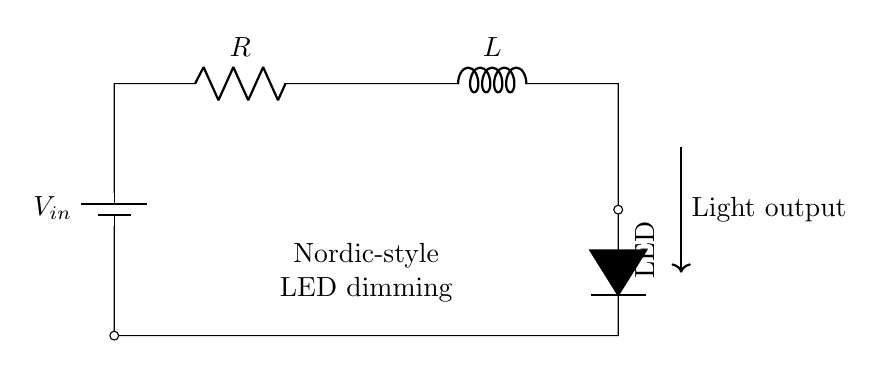What is the input voltage of this circuit? The input voltage, indicated by \(V_{in}\), represents the potential supplied by the battery connected at the top of the circuit. Since no specific value is provided in the diagram, we acknowledge it generically as \(V_{in}\).
Answer: \(V_{in}\) What type of components are present in this circuit? The circuit contains two fundamental components: a resistor \(R\) and an inductor \(L\). Additionally, there is a light-emitting diode (LED) connected as the load.
Answer: Resistor, Inductor, LED What is the function of the resistor in this RL circuit? The resistor \(R\) serves to limit the current flowing through the circuit, adjusting the light output from the LED here. In an RL circuit, it impacts the time constant and current behavior.
Answer: Current Limiting What happens to the LED light output if the resistance is increased? Increasing the resistance will typically decrease the current flowing through the circuit, which in turn lowers the brightness of the LED. This relationship highlights how resistance influences light output in dimming applications.
Answer: Decreases How can the inductance value affect the transient response in this circuit? The inductance \(L\) determines how quickly the current can change in response to the input voltage. A higher inductance value will result in slower current rise and fall times, contributing to smoother dimming effects.
Answer: Slower response What is the purpose of the inductor in this LED dimming circuit? The inductor \(L\) stores energy in its magnetic field and helps to smooth out current fluctuations, which is essential for achieving a consistent dimming effect for the LED. This is crucial in dimming applications using inductive components.
Answer: Energy Storage What is indicated by the arrow pointing to the light output? The arrow indicates the direction of light emitted from the LED, showing that the circuit is designed to produce light output as a primary function, associated with LED operation in dimming setups.
Answer: Light output 